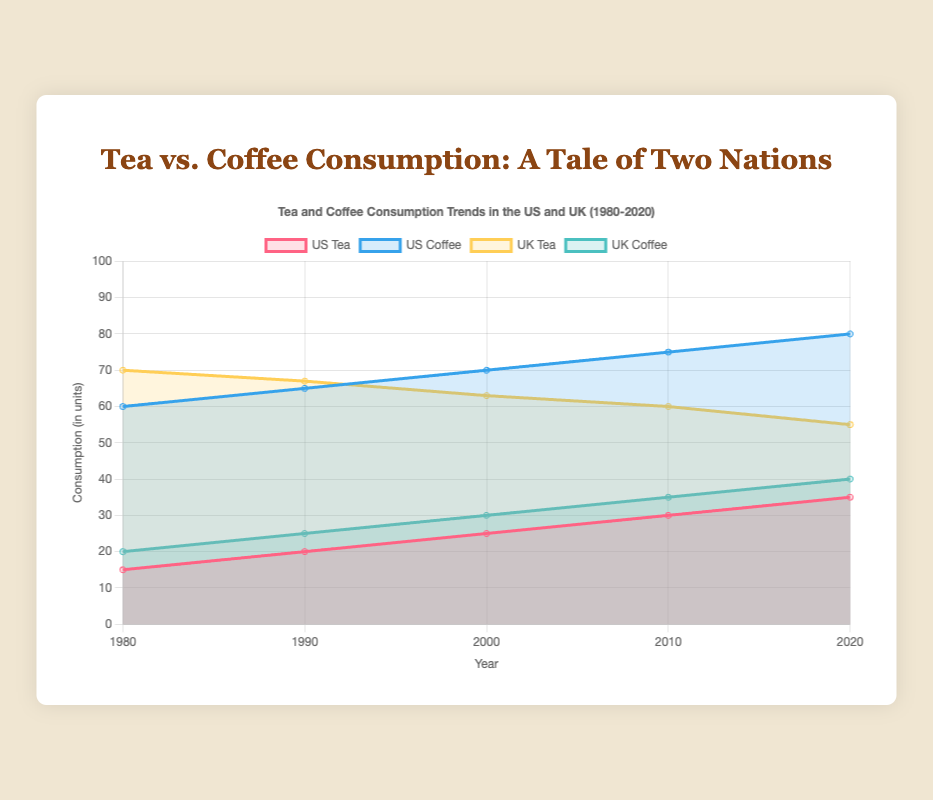What is the title of the chart? The title is displayed at the top of the chart and reads: "Tea and Coffee Consumption Trends in the US and UK (1980-2020)"
Answer: Tea and Coffee Consumption Trends in the US and UK (1980-2020) How many years are shown on the x-axis? The x-axis labels the years, and there are five specific years shown: 1980, 1990, 2000, 2010, and 2020
Answer: Five What color represents US Coffee consumption in the chart? The color representation can be determined by looking at the legend. US Coffee is represented by a blue color with rgba(54, 162, 235, 1) as the border color
Answer: Blue Which country had the higher tea consumption in 1980? By comparing the values for Tea in 1980 for both countries, the UK had 70 units, while the US had 15 units
Answer: UK What was the trend in tea consumption in the UK from 1980 to 2020? Observing the UK Tea line, the trend shows a decline from 70 units in 1980 to 55 units in 2020, indicating a decreasing trend
Answer: Decreasing Compare the US Coffee consumption and UK Tea consumption in 2020. Which was higher? The values for 2020 are: US Coffee 80 units, UK Tea 55 units. Since 80 is greater than 55, US Coffee consumption was higher in 2020
Answer: US Coffee consumption What is the average tea consumption in the US over the decades? The values for US Tea consumption are 15, 20, 25, 30, 35. Summing these gives 125. Dividing by 5 (number of years) gives an average of 25
Answer: 25 Which beverage in which country showed the most significant increase from 1980 to 2020? Calculating the increase: 
- US Tea: 35 - 15 = 20
- US Coffee: 80 - 60 = 20
- UK Tea: 55 - 70 = -15 (decrease)
- UK Coffee: 40 - 20 = 20. 
Both US Tea, US Coffee, and UK Coffee showed an increase of 20 units, so they have the most significant increase.
Answer: US Tea, US Coffee, and UK Coffee Between 1980 and 2020, did any beverage in any country show a consistent increase or decrease each decade? Checking the data:
- US Tea: Increased every decade
- US Coffee: Increased every decade
- UK Tea: Decreased every decade
- UK Coffee: Increased every decade. 
Each of them shows a consistent trend of either increase or decrease decade by decade.
Answer: Yes, all beverages showed consistent trends In 2000, was tea consumption higher in the UK or coffee consumption in the US? The values for 2000 are: UK Tea 63 units, US Coffee 70 units. Since 70 is greater than 63, US Coffee consumption was higher in 2000
Answer: US Coffee consumption 